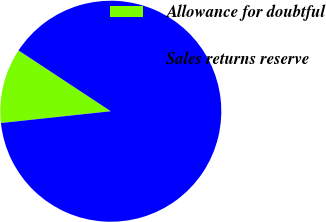<chart> <loc_0><loc_0><loc_500><loc_500><pie_chart><fcel>Allowance for doubtful<fcel>Sales returns reserve<nl><fcel>10.98%<fcel>89.02%<nl></chart> 